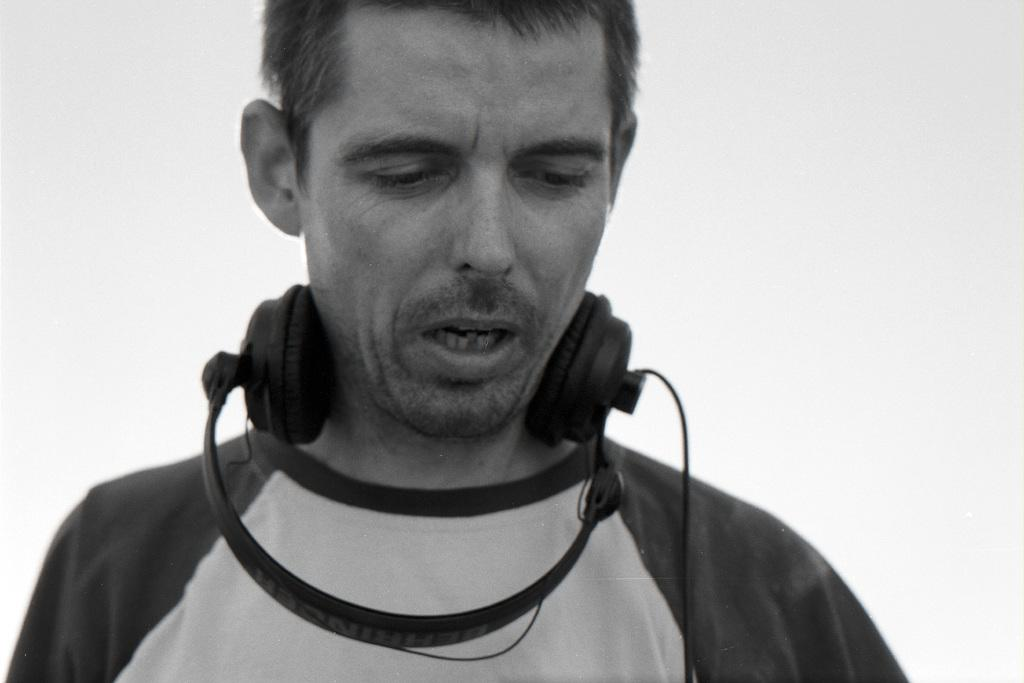What is the color scheme of the image? The image is black and white. Who is present in the image? There is a man in the image. What is the man wearing on his head? The man is wearing a headset. What can be observed about the background of the image? The background of the image is in a plain color. How many fangs can be seen on the man in the image? There are no fangs visible on the man in the image, as he is a human wearing a headset. What type of weather can be observed during the rainstorm in the image? There is no rainstorm present in the image; it is a black and white image featuring a man wearing a headset against a plain background. 